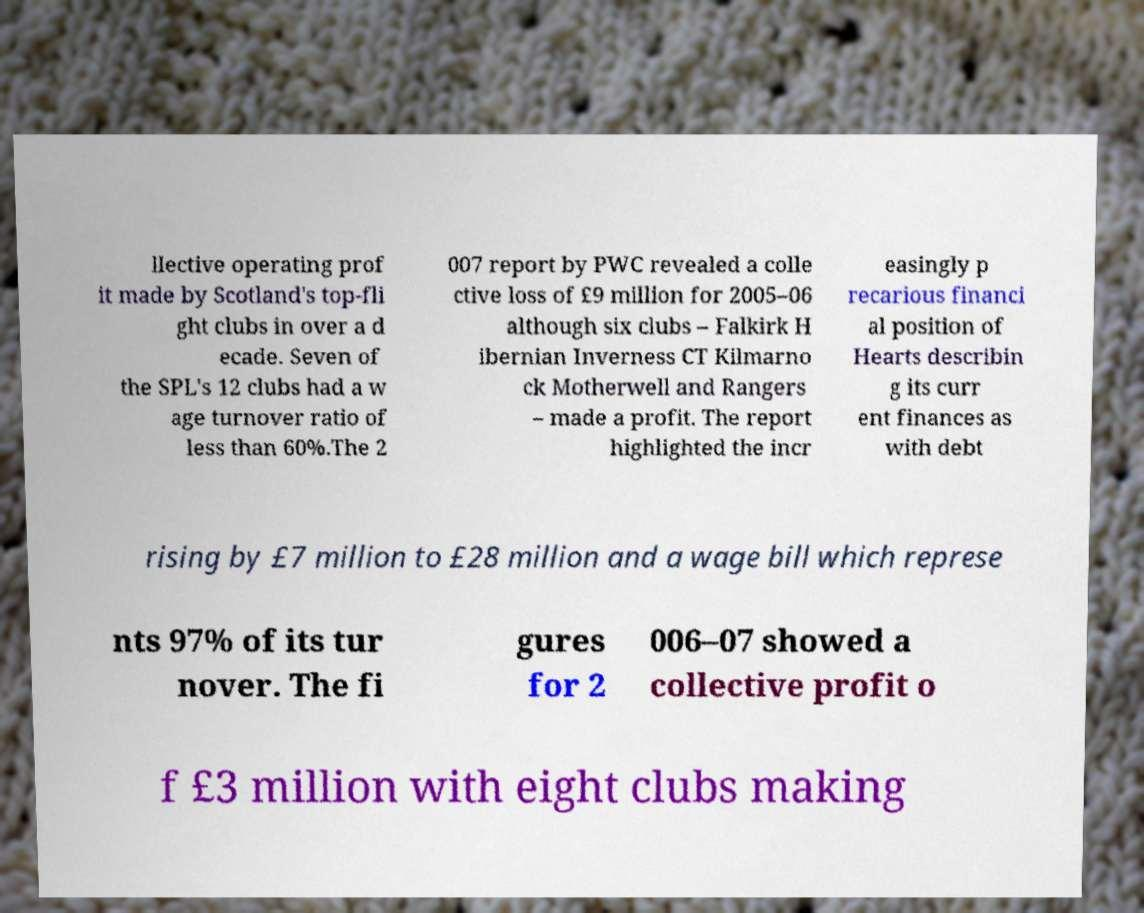Could you extract and type out the text from this image? llective operating prof it made by Scotland's top-fli ght clubs in over a d ecade. Seven of the SPL's 12 clubs had a w age turnover ratio of less than 60%.The 2 007 report by PWC revealed a colle ctive loss of £9 million for 2005–06 although six clubs – Falkirk H ibernian Inverness CT Kilmarno ck Motherwell and Rangers – made a profit. The report highlighted the incr easingly p recarious financi al position of Hearts describin g its curr ent finances as with debt rising by £7 million to £28 million and a wage bill which represe nts 97% of its tur nover. The fi gures for 2 006–07 showed a collective profit o f £3 million with eight clubs making 